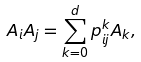Convert formula to latex. <formula><loc_0><loc_0><loc_500><loc_500>A _ { i } A _ { j } = \sum _ { k = 0 } ^ { d } p _ { i j } ^ { k } A _ { k } ,</formula> 